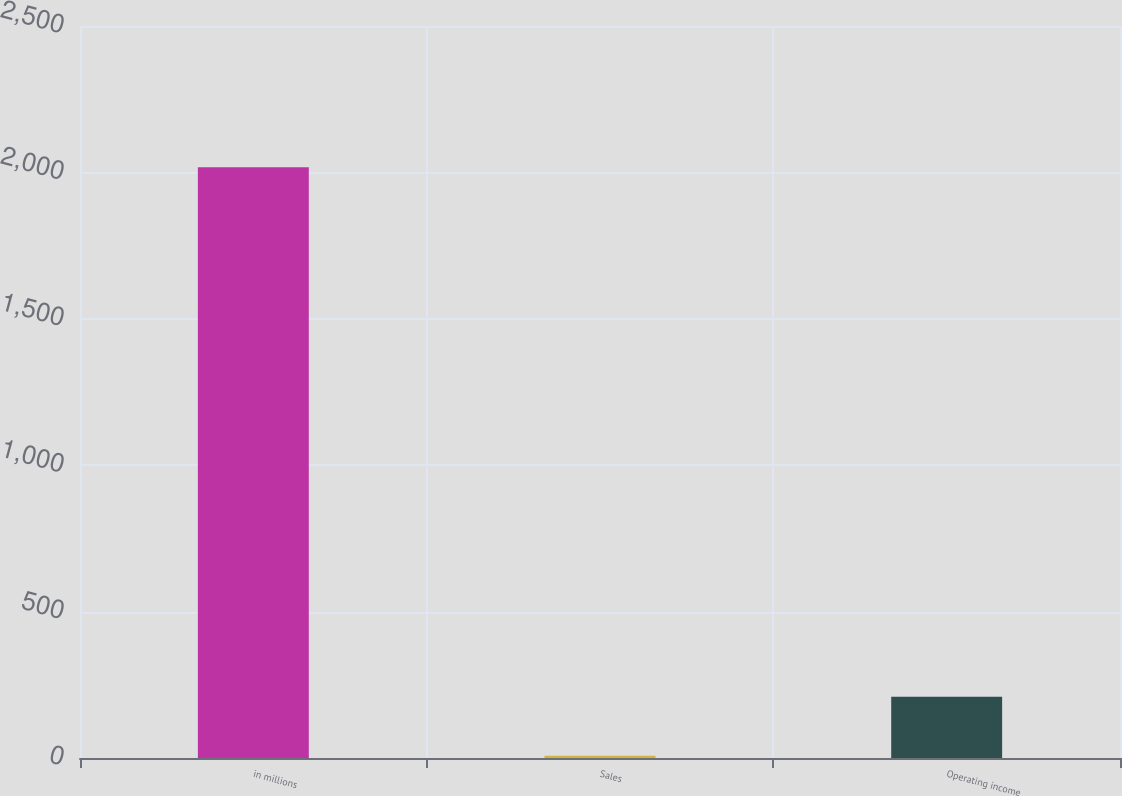Convert chart to OTSL. <chart><loc_0><loc_0><loc_500><loc_500><bar_chart><fcel>in millions<fcel>Sales<fcel>Operating income<nl><fcel>2018<fcel>8<fcel>209<nl></chart> 